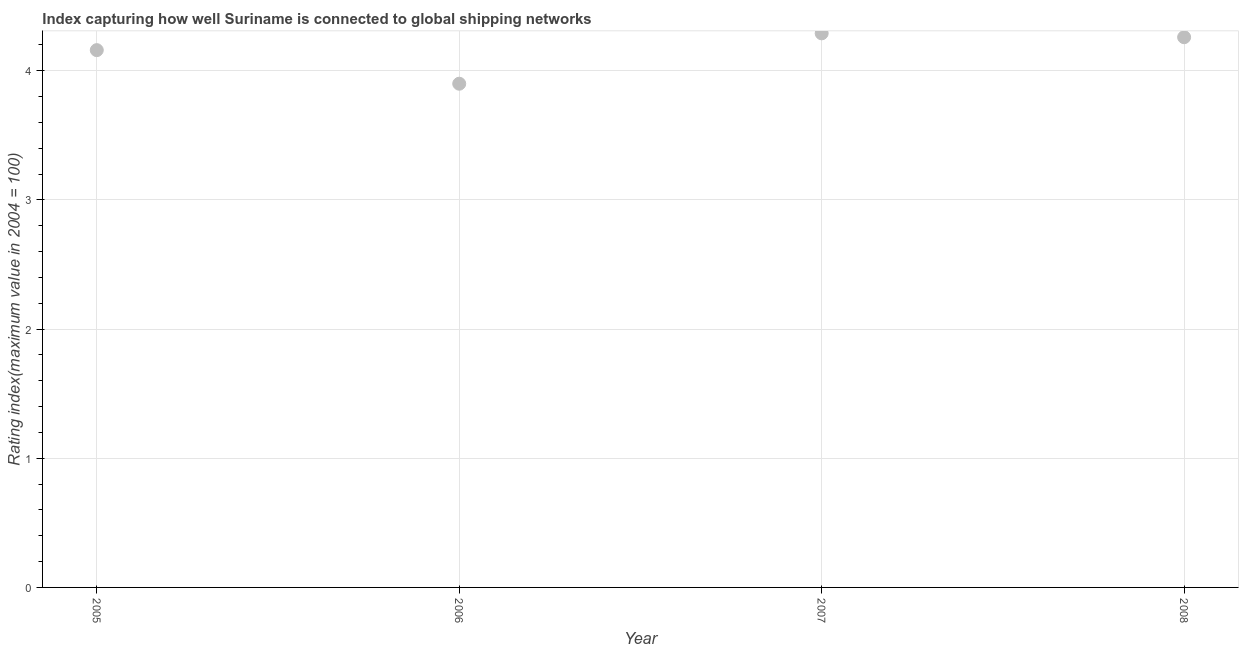What is the liner shipping connectivity index in 2008?
Keep it short and to the point. 4.26. Across all years, what is the maximum liner shipping connectivity index?
Provide a succinct answer. 4.29. What is the sum of the liner shipping connectivity index?
Give a very brief answer. 16.61. What is the difference between the liner shipping connectivity index in 2005 and 2006?
Offer a very short reply. 0.26. What is the average liner shipping connectivity index per year?
Offer a very short reply. 4.15. What is the median liner shipping connectivity index?
Keep it short and to the point. 4.21. Do a majority of the years between 2008 and 2005 (inclusive) have liner shipping connectivity index greater than 2.8 ?
Give a very brief answer. Yes. What is the ratio of the liner shipping connectivity index in 2006 to that in 2008?
Offer a very short reply. 0.92. What is the difference between the highest and the second highest liner shipping connectivity index?
Give a very brief answer. 0.03. What is the difference between the highest and the lowest liner shipping connectivity index?
Your answer should be compact. 0.39. How many dotlines are there?
Ensure brevity in your answer.  1. How many years are there in the graph?
Provide a succinct answer. 4. What is the difference between two consecutive major ticks on the Y-axis?
Your answer should be compact. 1. Are the values on the major ticks of Y-axis written in scientific E-notation?
Your answer should be very brief. No. What is the title of the graph?
Ensure brevity in your answer.  Index capturing how well Suriname is connected to global shipping networks. What is the label or title of the X-axis?
Ensure brevity in your answer.  Year. What is the label or title of the Y-axis?
Keep it short and to the point. Rating index(maximum value in 2004 = 100). What is the Rating index(maximum value in 2004 = 100) in 2005?
Your answer should be compact. 4.16. What is the Rating index(maximum value in 2004 = 100) in 2006?
Provide a short and direct response. 3.9. What is the Rating index(maximum value in 2004 = 100) in 2007?
Offer a terse response. 4.29. What is the Rating index(maximum value in 2004 = 100) in 2008?
Offer a very short reply. 4.26. What is the difference between the Rating index(maximum value in 2004 = 100) in 2005 and 2006?
Offer a very short reply. 0.26. What is the difference between the Rating index(maximum value in 2004 = 100) in 2005 and 2007?
Give a very brief answer. -0.13. What is the difference between the Rating index(maximum value in 2004 = 100) in 2006 and 2007?
Your response must be concise. -0.39. What is the difference between the Rating index(maximum value in 2004 = 100) in 2006 and 2008?
Make the answer very short. -0.36. What is the difference between the Rating index(maximum value in 2004 = 100) in 2007 and 2008?
Your response must be concise. 0.03. What is the ratio of the Rating index(maximum value in 2004 = 100) in 2005 to that in 2006?
Your answer should be very brief. 1.07. What is the ratio of the Rating index(maximum value in 2004 = 100) in 2006 to that in 2007?
Give a very brief answer. 0.91. What is the ratio of the Rating index(maximum value in 2004 = 100) in 2006 to that in 2008?
Offer a very short reply. 0.92. 